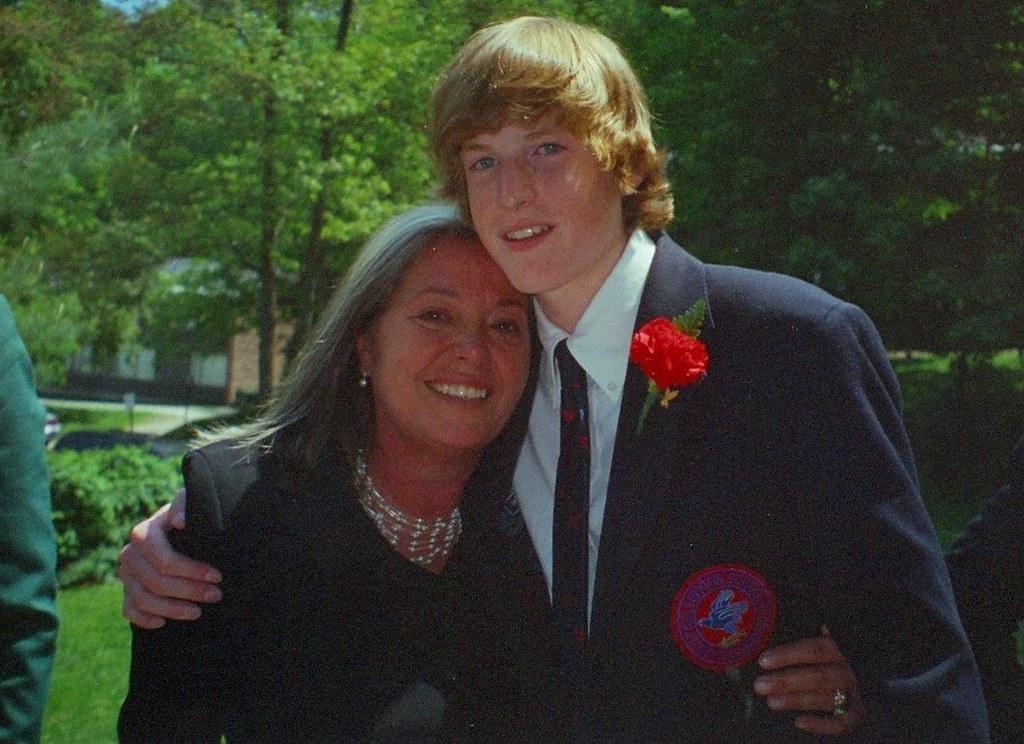In one or two sentences, can you explain what this image depicts? There is one woman and a man is standing at the bottom of this image. We can see trees in the background. 